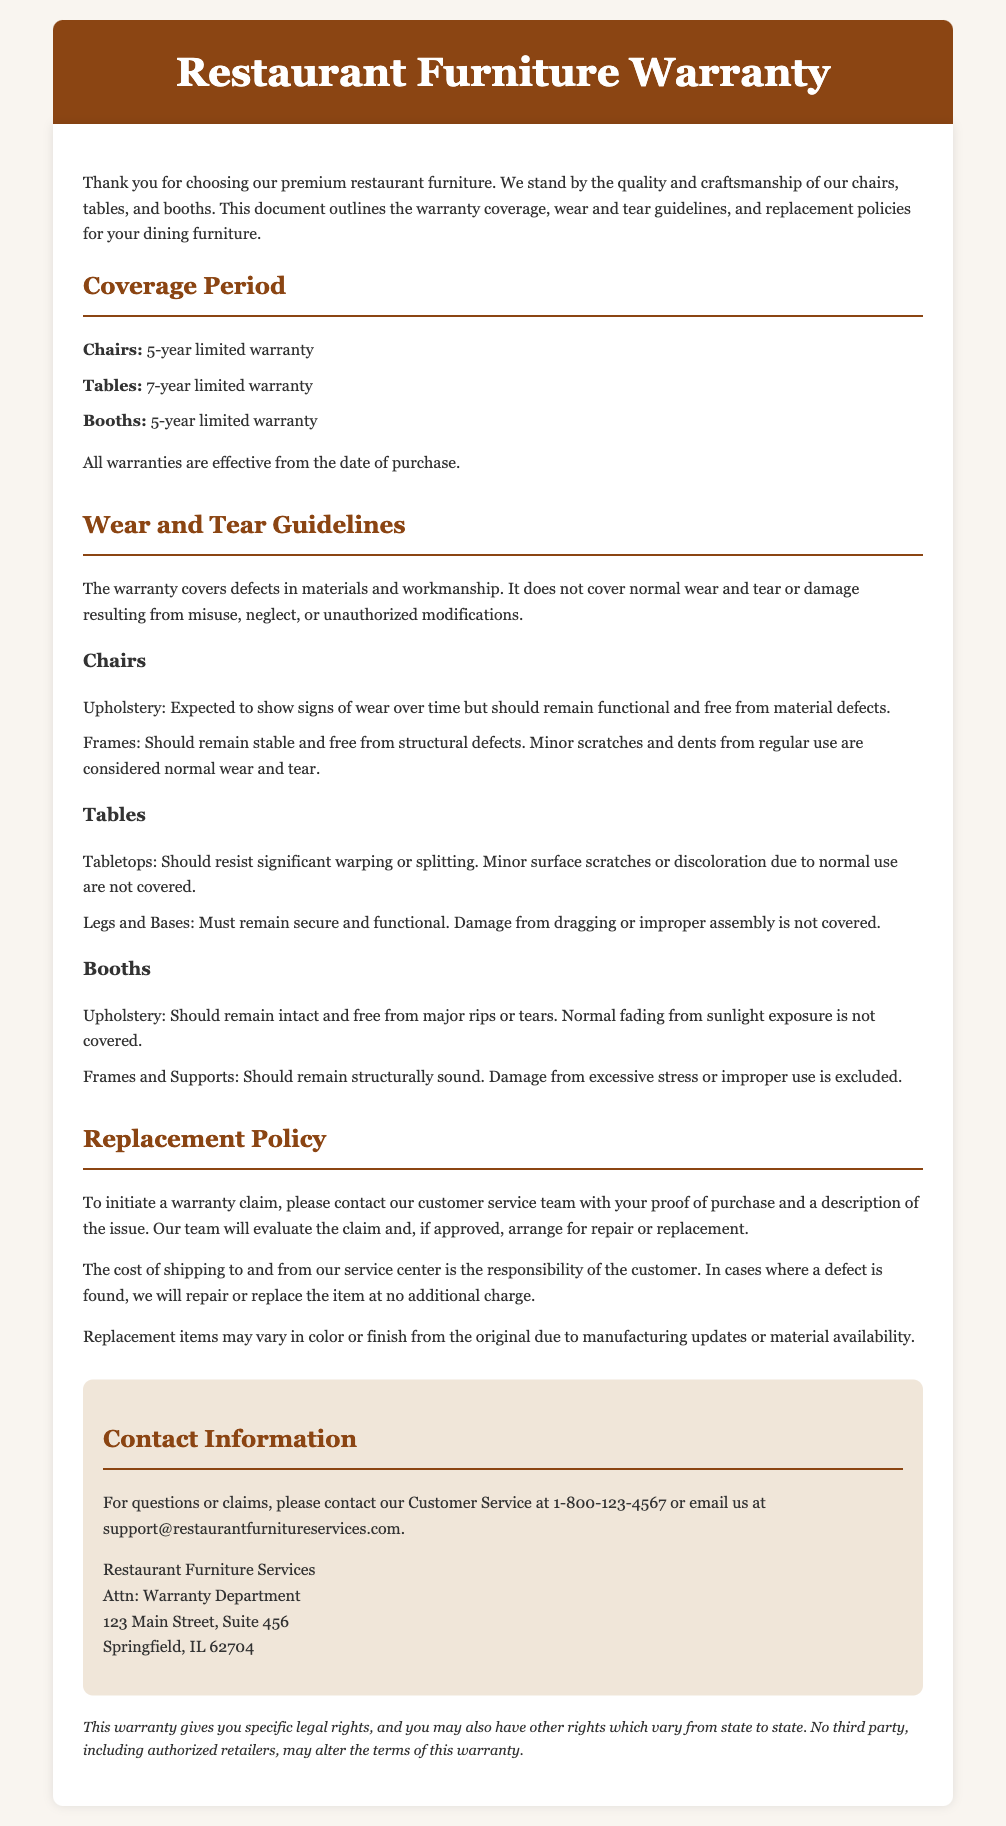what is the coverage period for chairs? The coverage period for chairs is specified in the warranty section of the document as a limited warranty duration.
Answer: 5-year limited warranty what damages are not covered under the warranty? The document outlines that normal wear and tear or damage stemming from misuse, neglect, or unauthorized modifications are not covered.
Answer: Normal wear and tear how can I initiate a warranty claim? The procedure to initiate a warranty claim is described under the replacement policy section.
Answer: Contact customer service what is the warranty period for tables? The warranty specifies the duration for different types of furniture items, including tables.
Answer: 7-year limited warranty what should customers send to start a warranty claim? The document states what customers need to provide when initiating a warranty claim.
Answer: Proof of purchase what happens if a defect is found during a warranty claim? The document explains the outcome when a defect is discovered after a claim evaluation.
Answer: Repair or replace do replacement items always match the original? The warranty details the characteristics of replacement items regarding their appearance relative to the original.
Answer: May vary in color or finish what is the responsibility of the customer regarding shipping for replacement items? The document specifies the shipping responsibilities concerning warranty claims.
Answer: Customer responsibility how long is the warranty for booths? The warranty includes specific periods for each type of furniture, including booths.
Answer: 5-year limited warranty 